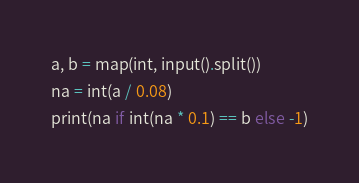<code> <loc_0><loc_0><loc_500><loc_500><_Python_>a, b = map(int, input().split())
na = int(a / 0.08)
print(na if int(na * 0.1) == b else -1)</code> 